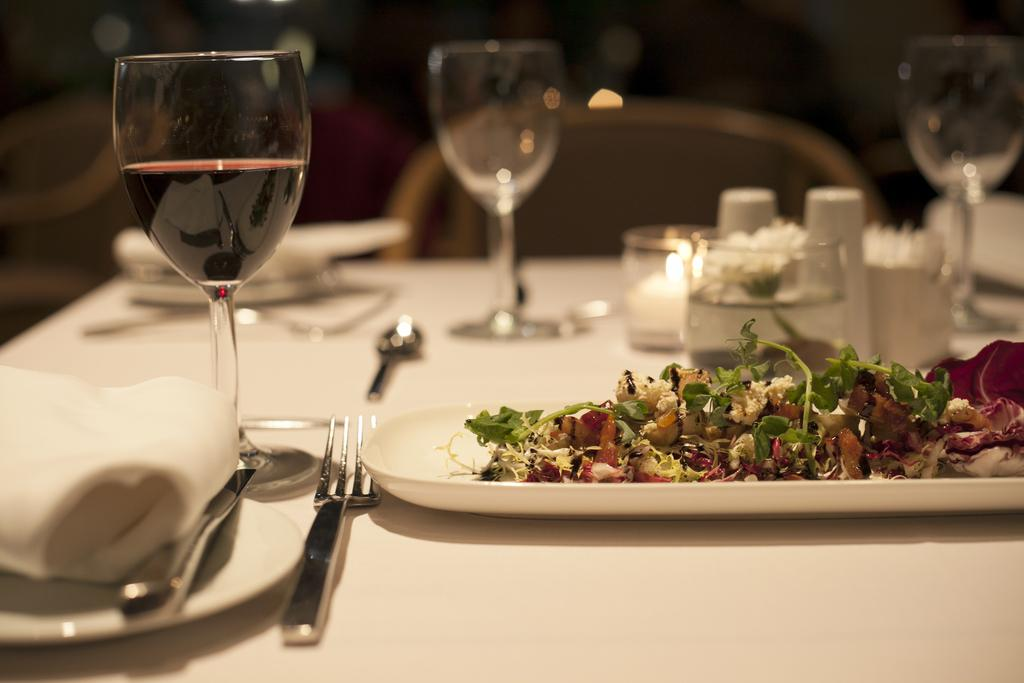What is the main object in the center of the image? There is a table in the center of the image. What can be found on the table? Food items, wine glasses, plates, forks, and napkins are present on the table. Can you describe the seating arrangement in the image? There is at least one chair in the background of the image. What type of popcorn is being served in the image? There is no popcorn present in the image. How many attempts were made to create the perfect table setting in the image? The image does not provide information about the number of attempts made to create the table setting. 